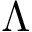<formula> <loc_0><loc_0><loc_500><loc_500>\Lambda</formula> 